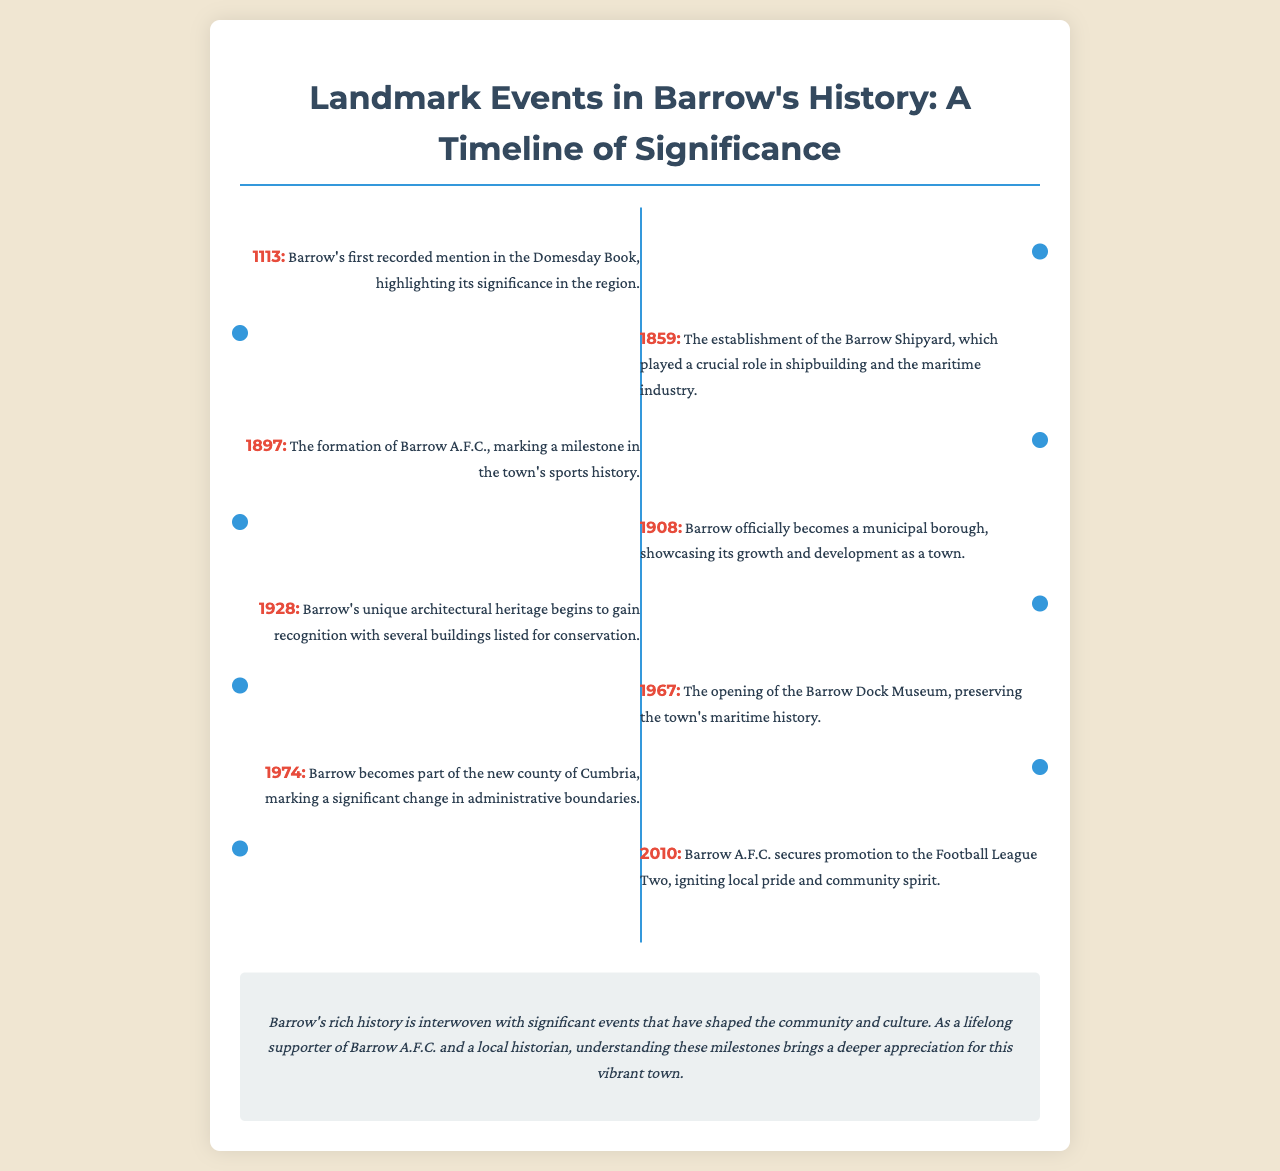What year was Barrow first mentioned in the Domesday Book? The document states that Barrow's first recorded mention occurred in the year 1113.
Answer: 1113 When was Barrow A.F.C. formed? According to the timeline, Barrow A.F.C. was formed in 1897.
Answer: 1897 What significant event occurred in Barrow in 1908? The event mentioned in 1908 is that Barrow officially became a municipal borough.
Answer: Municipal borough How many years passed between the establishment of Barrow Shipyard and Barrow's recognition for its architectural heritage? The establishment of the Barrow Shipyard was in 1859, and the recognition for its architectural heritage began in 1928. Calculating the difference gives 1928 - 1859 = 69 years.
Answer: 69 years What museum opened in Barrow in 1967? The document specifies that the Barrow Dock Museum opened in 1967.
Answer: Barrow Dock Museum What was a significant change in Barrow's administrative status in 1974? Barrow becoming part of the new county of Cumbria in 1974 is the significant change mentioned.
Answer: New county of Cumbria Which sports milestone was highlighted in 2010 for Barrow A.F.C.? In 2010, Barrow A.F.C. secured promotion to the Football League Two.
Answer: Promotion to Football League Two 